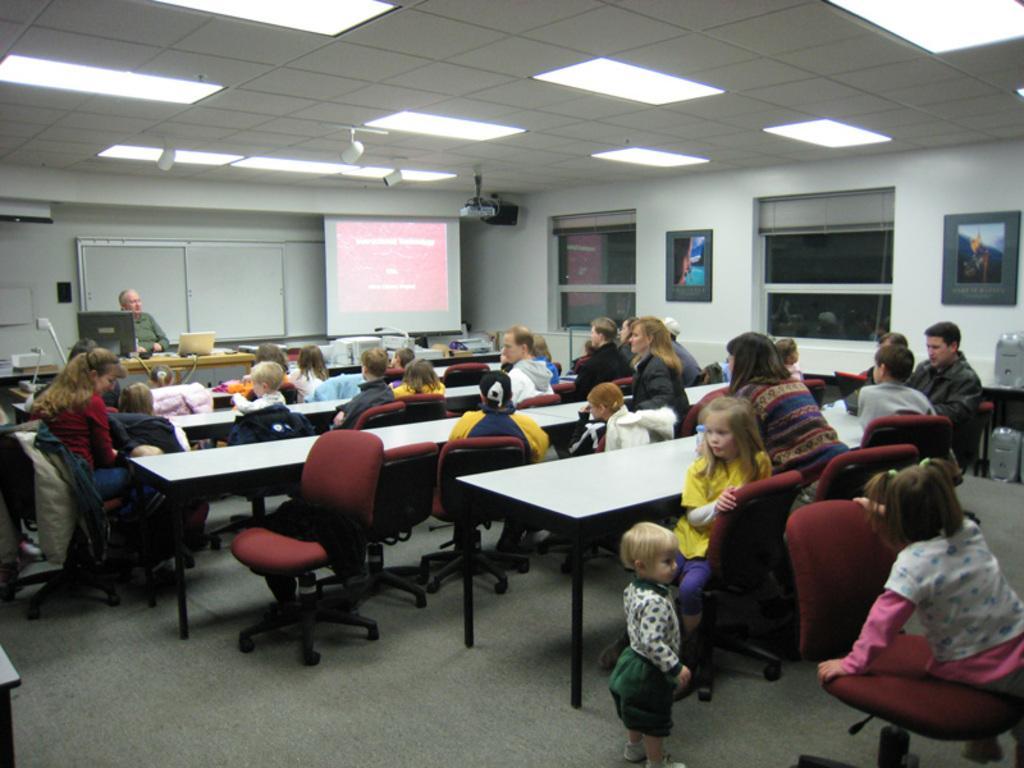Describe this image in one or two sentences. A group of people sitting in the room in front of the desk and the room has projector and some lights above the benches and also windows and the photo frames on the right side of the wall. 